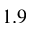Convert formula to latex. <formula><loc_0><loc_0><loc_500><loc_500>1 . 9</formula> 